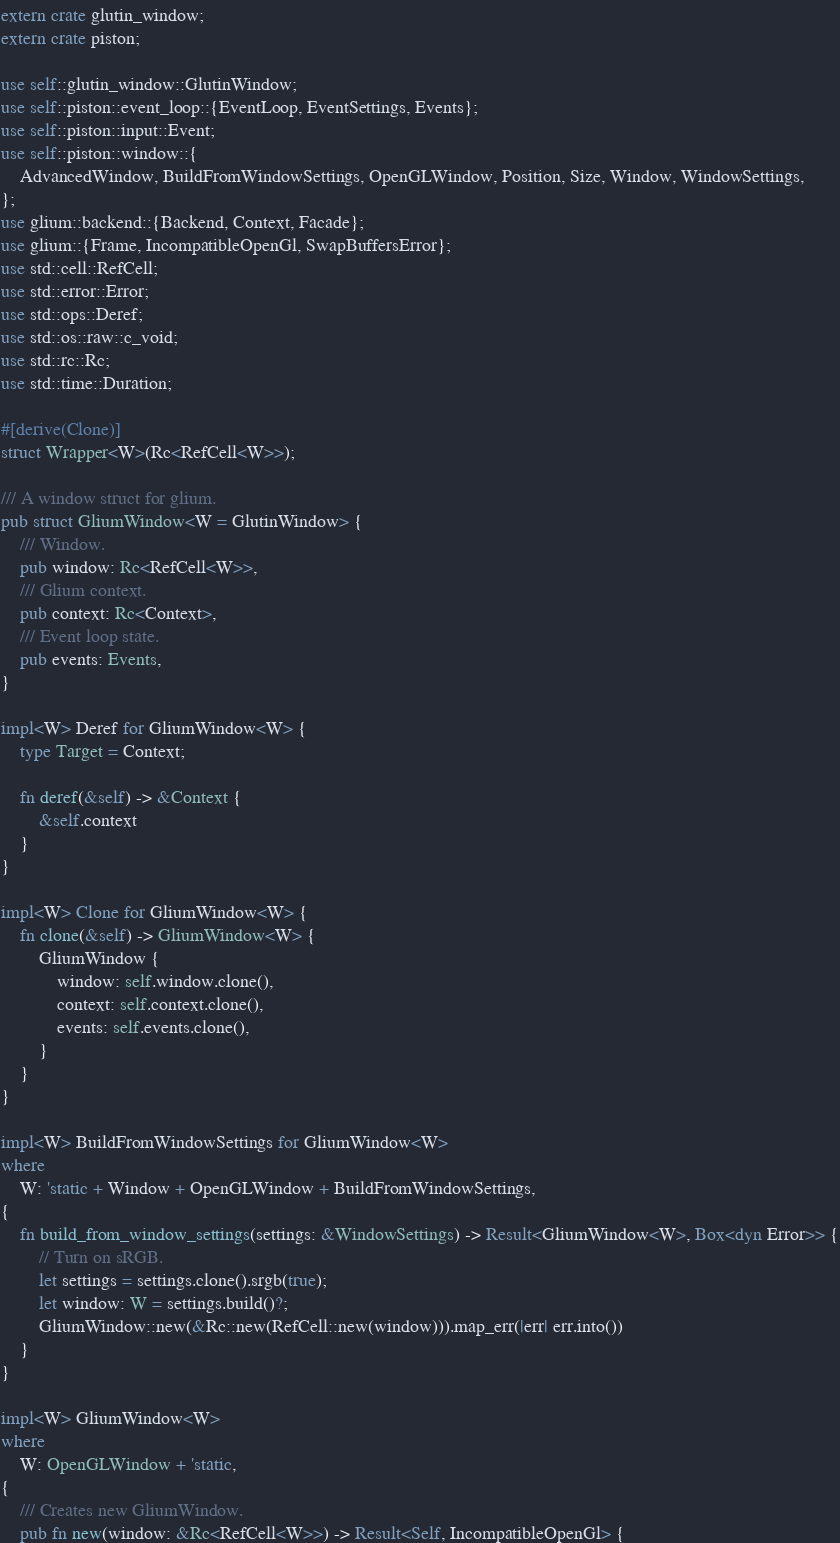Convert code to text. <code><loc_0><loc_0><loc_500><loc_500><_Rust_>extern crate glutin_window;
extern crate piston;

use self::glutin_window::GlutinWindow;
use self::piston::event_loop::{EventLoop, EventSettings, Events};
use self::piston::input::Event;
use self::piston::window::{
    AdvancedWindow, BuildFromWindowSettings, OpenGLWindow, Position, Size, Window, WindowSettings,
};
use glium::backend::{Backend, Context, Facade};
use glium::{Frame, IncompatibleOpenGl, SwapBuffersError};
use std::cell::RefCell;
use std::error::Error;
use std::ops::Deref;
use std::os::raw::c_void;
use std::rc::Rc;
use std::time::Duration;

#[derive(Clone)]
struct Wrapper<W>(Rc<RefCell<W>>);

/// A window struct for glium.
pub struct GliumWindow<W = GlutinWindow> {
    /// Window.
    pub window: Rc<RefCell<W>>,
    /// Glium context.
    pub context: Rc<Context>,
    /// Event loop state.
    pub events: Events,
}

impl<W> Deref for GliumWindow<W> {
    type Target = Context;

    fn deref(&self) -> &Context {
        &self.context
    }
}

impl<W> Clone for GliumWindow<W> {
    fn clone(&self) -> GliumWindow<W> {
        GliumWindow {
            window: self.window.clone(),
            context: self.context.clone(),
            events: self.events.clone(),
        }
    }
}

impl<W> BuildFromWindowSettings for GliumWindow<W>
where
    W: 'static + Window + OpenGLWindow + BuildFromWindowSettings,
{
    fn build_from_window_settings(settings: &WindowSettings) -> Result<GliumWindow<W>, Box<dyn Error>> {
        // Turn on sRGB.
        let settings = settings.clone().srgb(true);
        let window: W = settings.build()?;
        GliumWindow::new(&Rc::new(RefCell::new(window))).map_err(|err| err.into())
    }
}

impl<W> GliumWindow<W>
where
    W: OpenGLWindow + 'static,
{
    /// Creates new GliumWindow.
    pub fn new(window: &Rc<RefCell<W>>) -> Result<Self, IncompatibleOpenGl> {</code> 